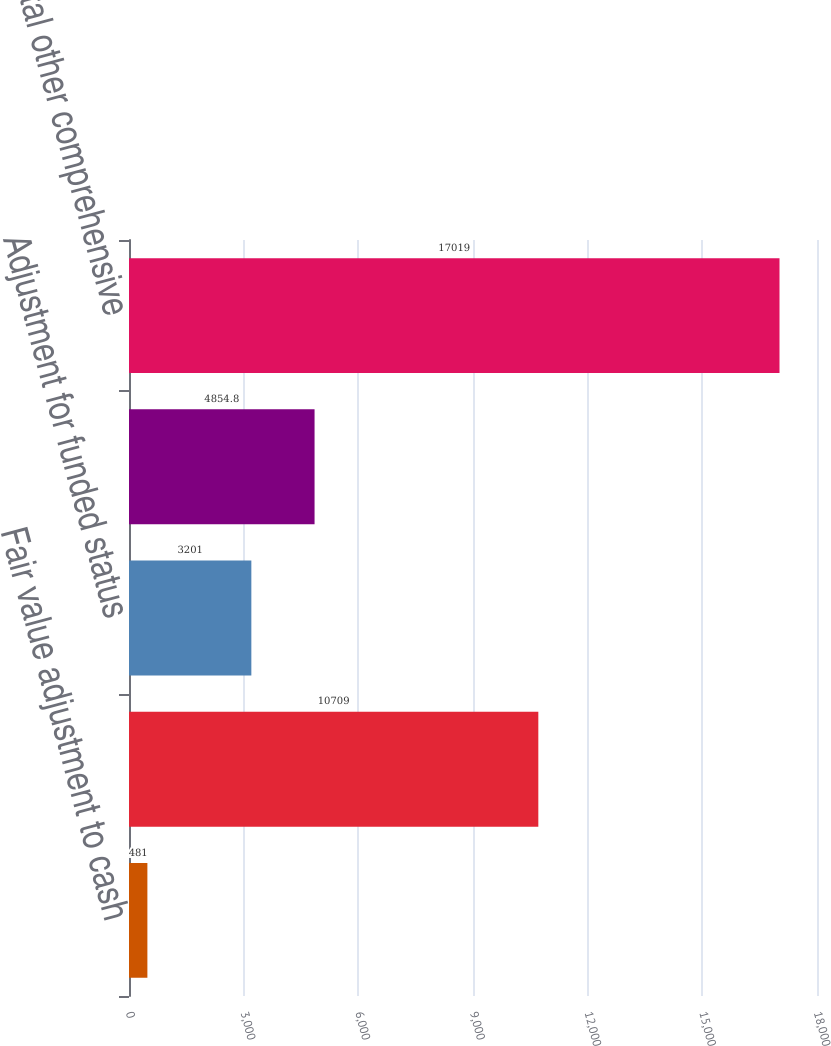Convert chart. <chart><loc_0><loc_0><loc_500><loc_500><bar_chart><fcel>Fair value adjustment to cash<fcel>Reclassification adjustment<fcel>Adjustment for funded status<fcel>Amortization of pension and<fcel>Total other comprehensive<nl><fcel>481<fcel>10709<fcel>3201<fcel>4854.8<fcel>17019<nl></chart> 